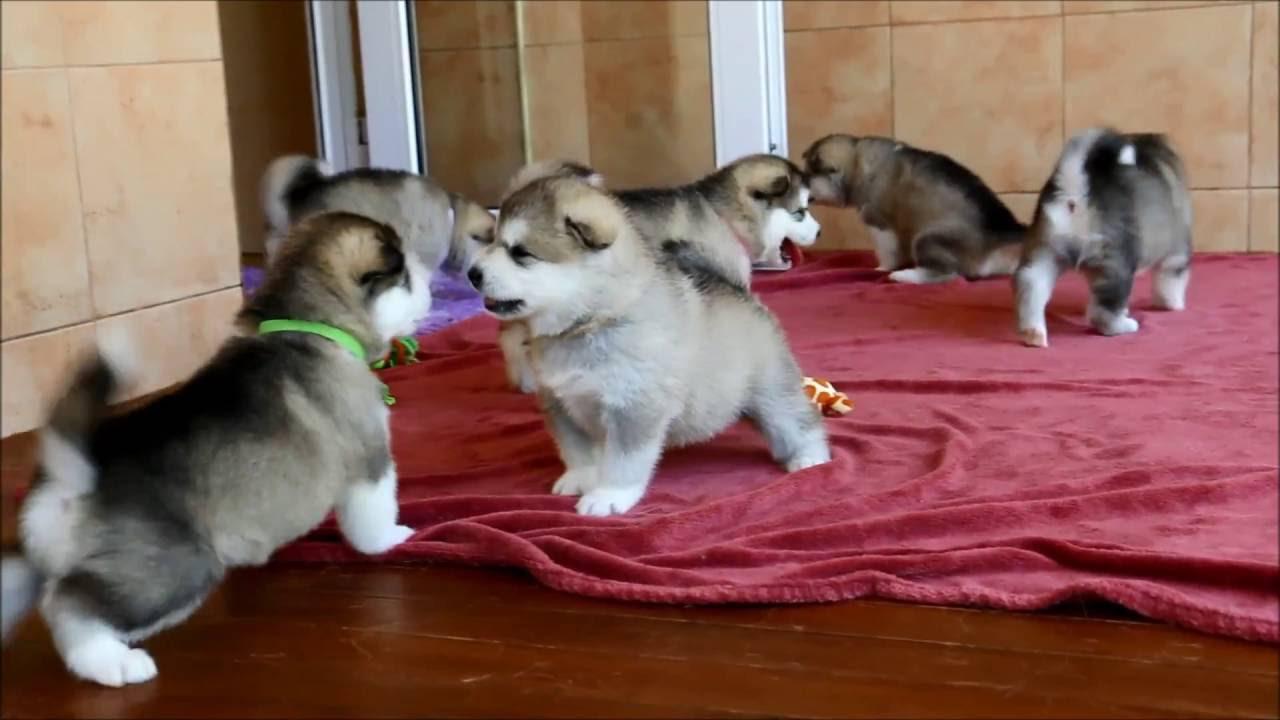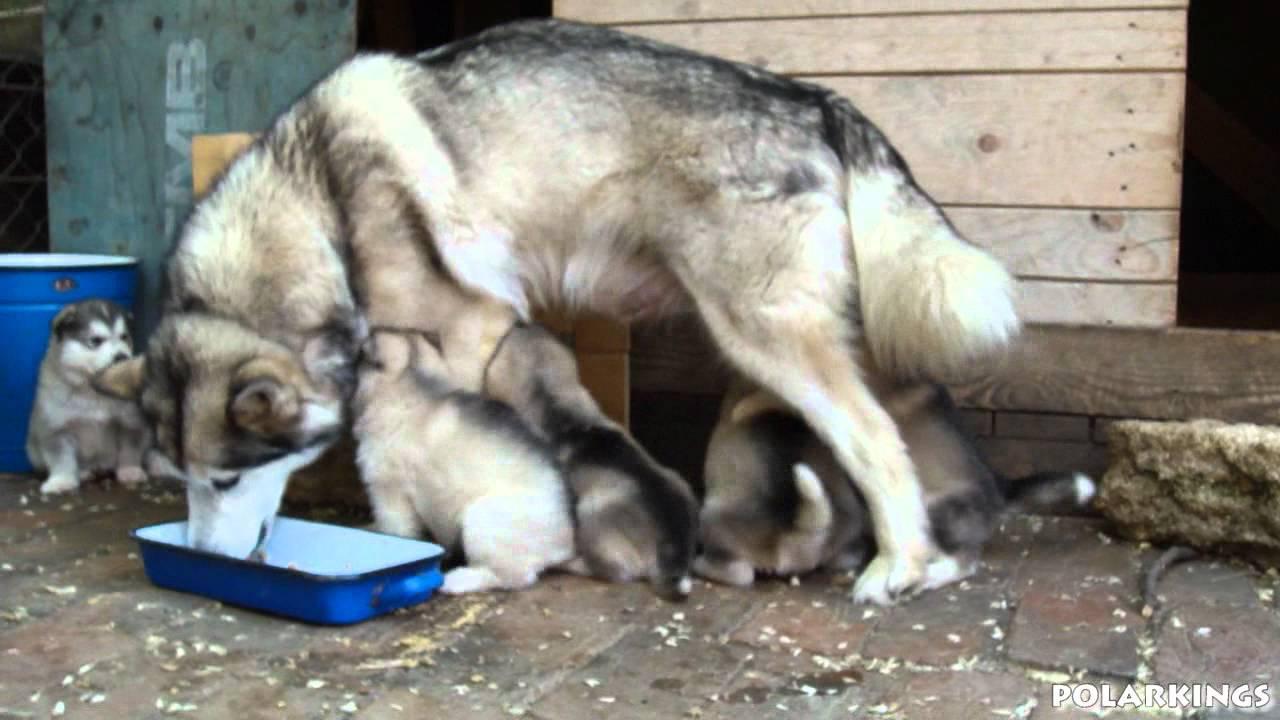The first image is the image on the left, the second image is the image on the right. Considering the images on both sides, is "There are two dogs in the image pair" valid? Answer yes or no. No. The first image is the image on the left, the second image is the image on the right. Examine the images to the left and right. Is the description "There are dogs standing." accurate? Answer yes or no. Yes. 